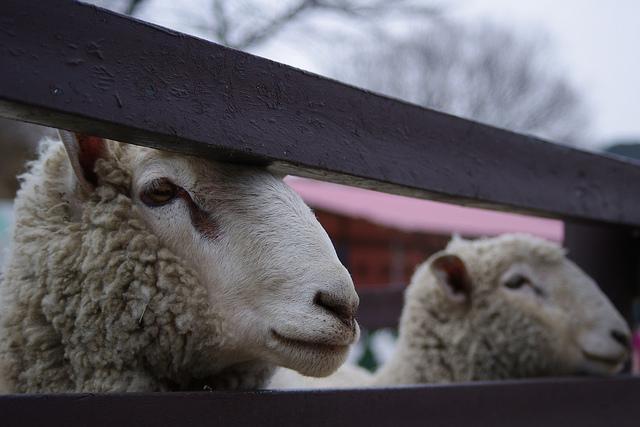How many sheep are in the picture?
Give a very brief answer. 2. How many sheep are in the photo?
Give a very brief answer. 2. 